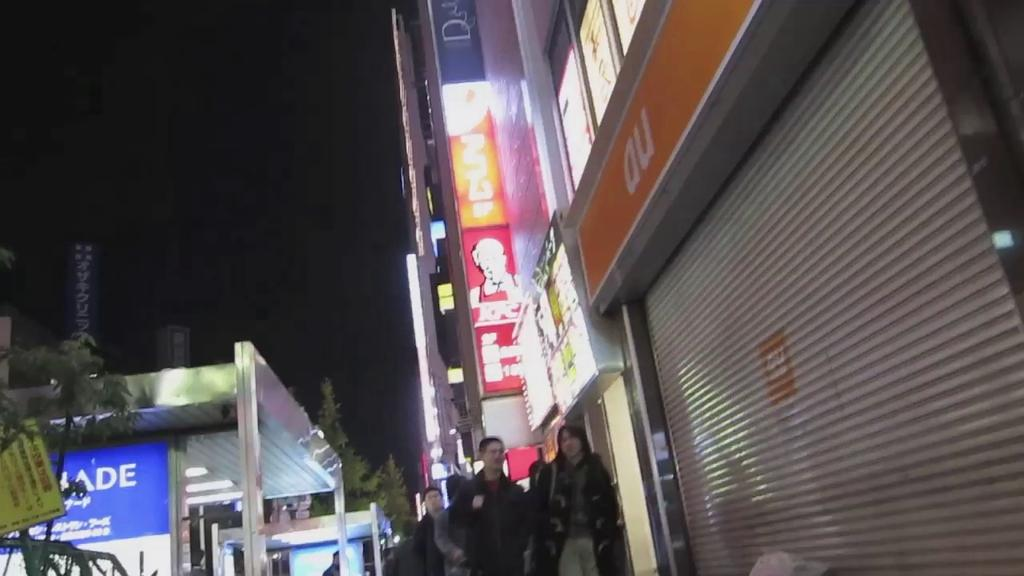Who or what can be seen in the image? There are persons in the image. What type of structures are present in the image? There are buildings in the image. Are there any advertisements or signs on the buildings? Yes, there are hoardings on the buildings. What can be seen in the distance in the image? There are trees visible in the background of the image. What color is the curtain hanging in the image? There is no curtain present in the image. How many matches are being used by the persons in the image? There are no matches visible in the image. 